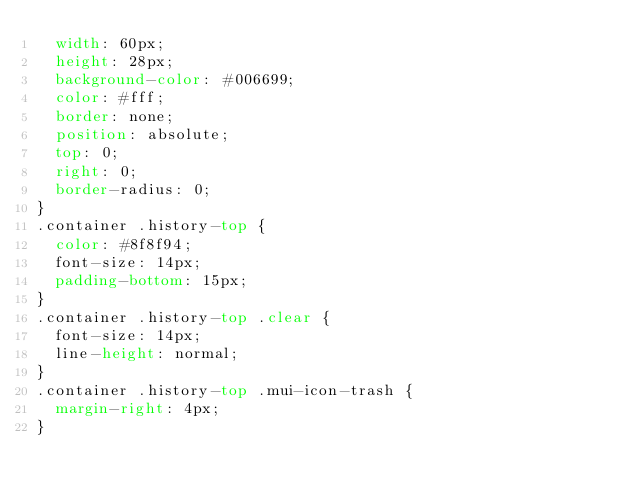Convert code to text. <code><loc_0><loc_0><loc_500><loc_500><_CSS_>  width: 60px;
  height: 28px;
  background-color: #006699;
  color: #fff;
  border: none;
  position: absolute;
  top: 0;
  right: 0;
  border-radius: 0;
}
.container .history-top {
  color: #8f8f94;
  font-size: 14px;
  padding-bottom: 15px;
}
.container .history-top .clear {
  font-size: 14px;
  line-height: normal;
}
.container .history-top .mui-icon-trash {
  margin-right: 4px;
}
</code> 